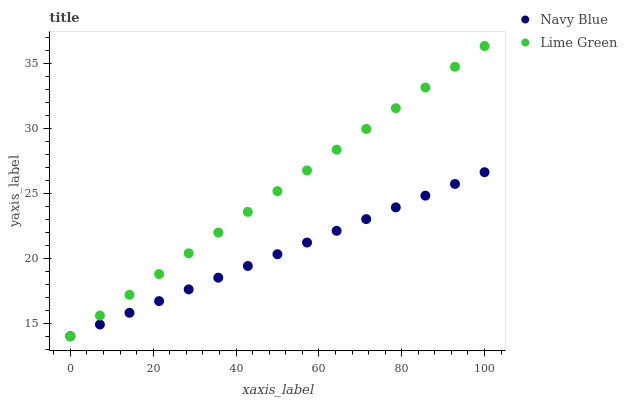Does Navy Blue have the minimum area under the curve?
Answer yes or no. Yes. Does Lime Green have the maximum area under the curve?
Answer yes or no. Yes. Does Lime Green have the minimum area under the curve?
Answer yes or no. No. Is Lime Green the smoothest?
Answer yes or no. Yes. Is Navy Blue the roughest?
Answer yes or no. Yes. Is Lime Green the roughest?
Answer yes or no. No. Does Navy Blue have the lowest value?
Answer yes or no. Yes. Does Lime Green have the highest value?
Answer yes or no. Yes. Does Lime Green intersect Navy Blue?
Answer yes or no. Yes. Is Lime Green less than Navy Blue?
Answer yes or no. No. Is Lime Green greater than Navy Blue?
Answer yes or no. No. 